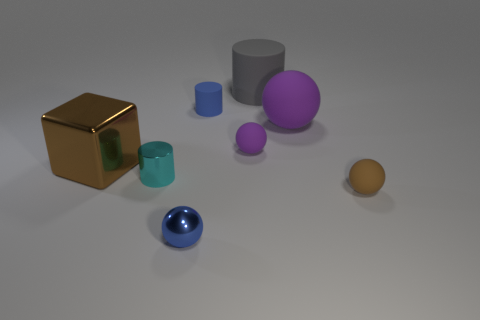Is there a small blue matte object that has the same shape as the small purple object?
Give a very brief answer. No. What number of things are either matte objects that are behind the big metal object or large brown rubber balls?
Offer a terse response. 4. What size is the rubber ball that is the same color as the big metallic block?
Offer a terse response. Small. Do the small rubber object behind the tiny purple thing and the cylinder in front of the big purple rubber object have the same color?
Your response must be concise. No. What size is the cube?
Give a very brief answer. Large. How many large things are gray cylinders or matte spheres?
Make the answer very short. 2. There is a matte cylinder that is the same size as the cyan thing; what is its color?
Your answer should be very brief. Blue. How many other things are the same shape as the tiny blue matte object?
Your answer should be compact. 2. Are there any other yellow cubes made of the same material as the cube?
Your response must be concise. No. Is the material of the purple sphere right of the big gray thing the same as the brown object that is left of the tiny blue metal thing?
Offer a terse response. No. 